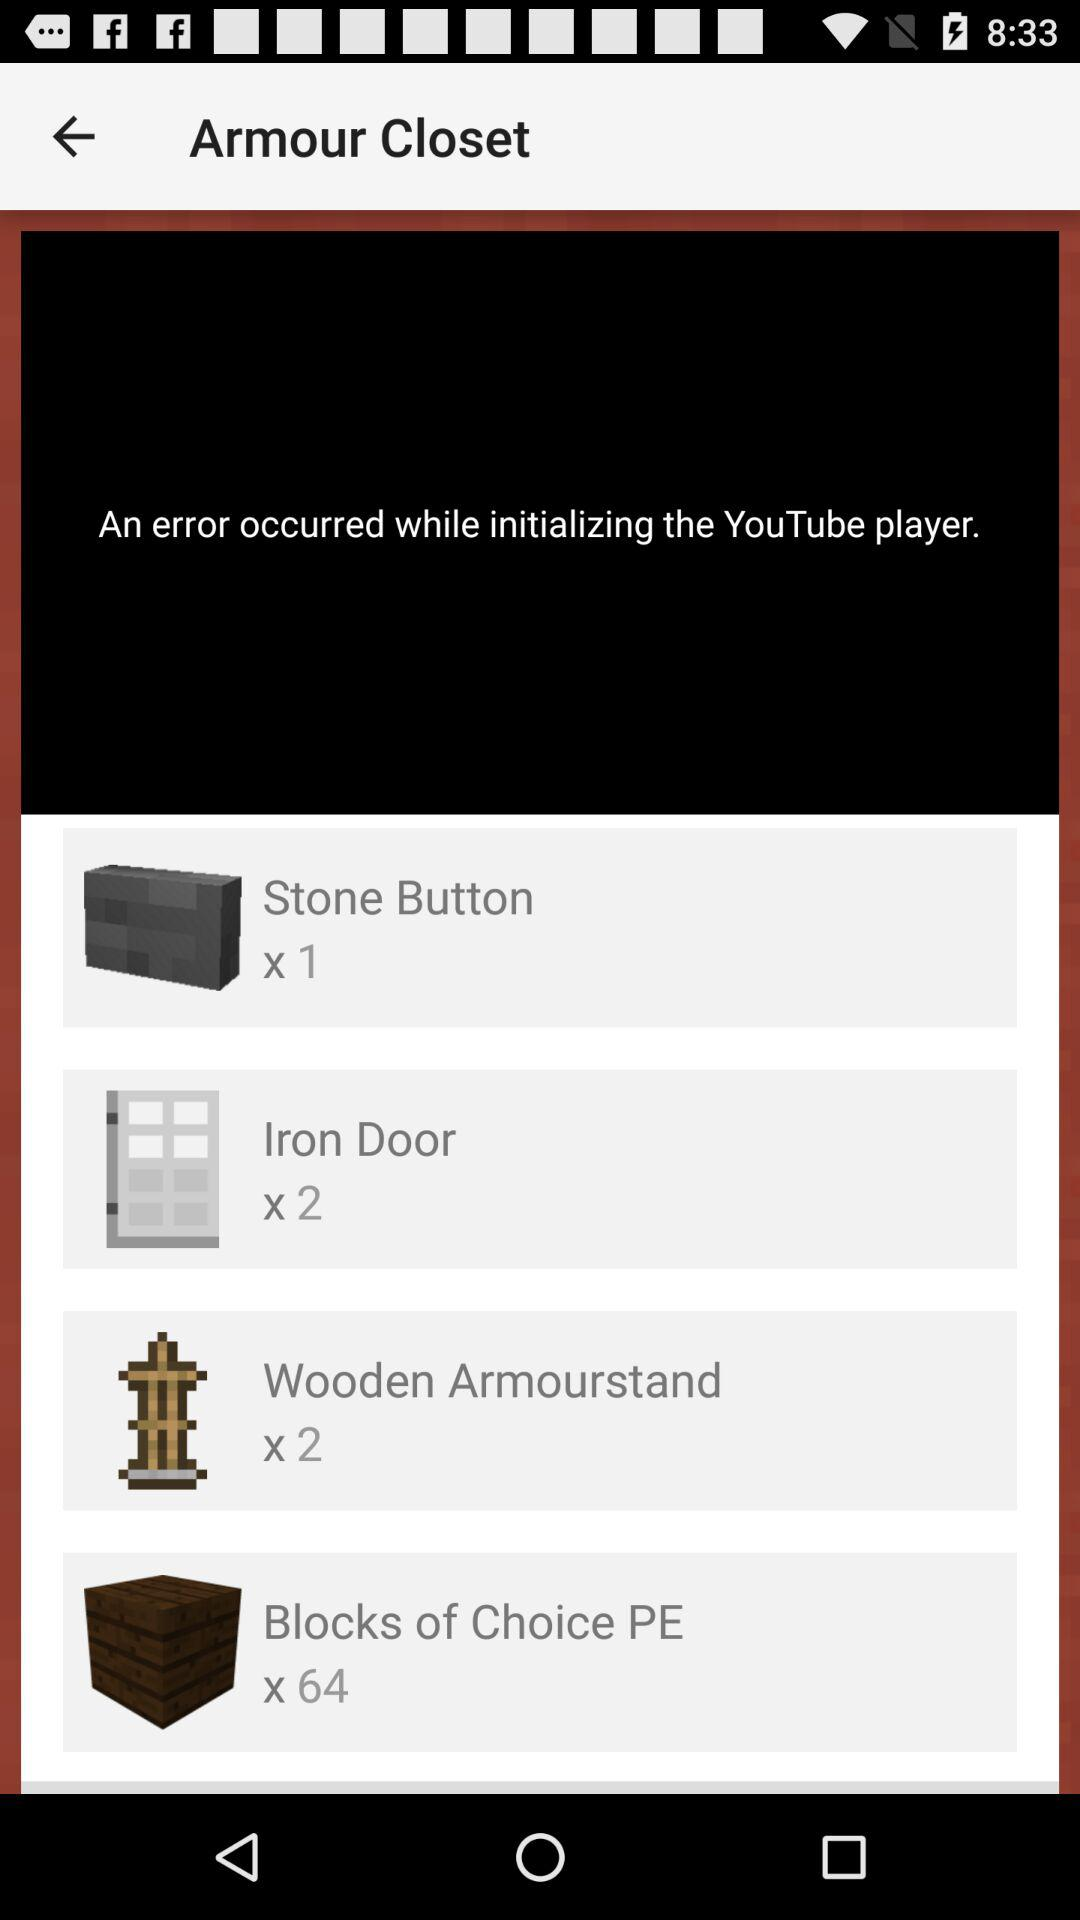How many items are in the inventory that have a quantity of 2 or more?
Answer the question using a single word or phrase. 3 